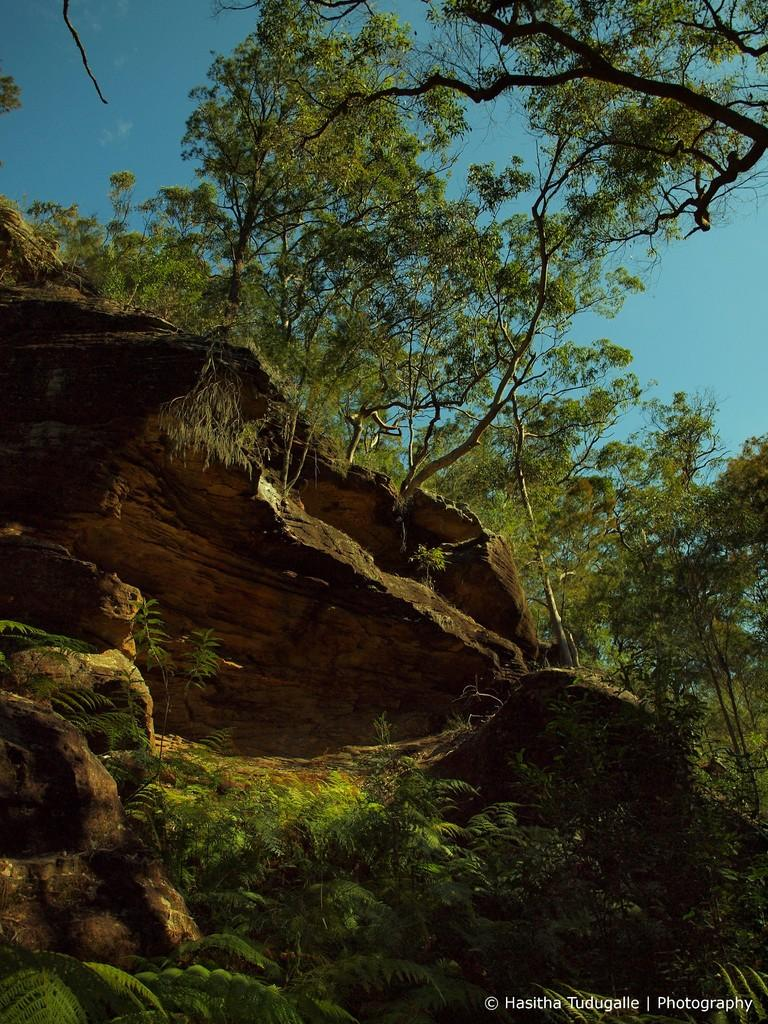What type of natural elements can be seen in the image? There are rocks, trees, and plants in the image. What part of the natural environment is visible in the image? The sky is visible in the image. How many types of vegetation are present in the image? There are two types of vegetation: trees and plants. What type of development can be seen in the image? There is no development visible in the image; it features natural elements such as rocks, trees, plants, and the sky. Can you see any arms in the image? There are no arms or human figures present in the image. 